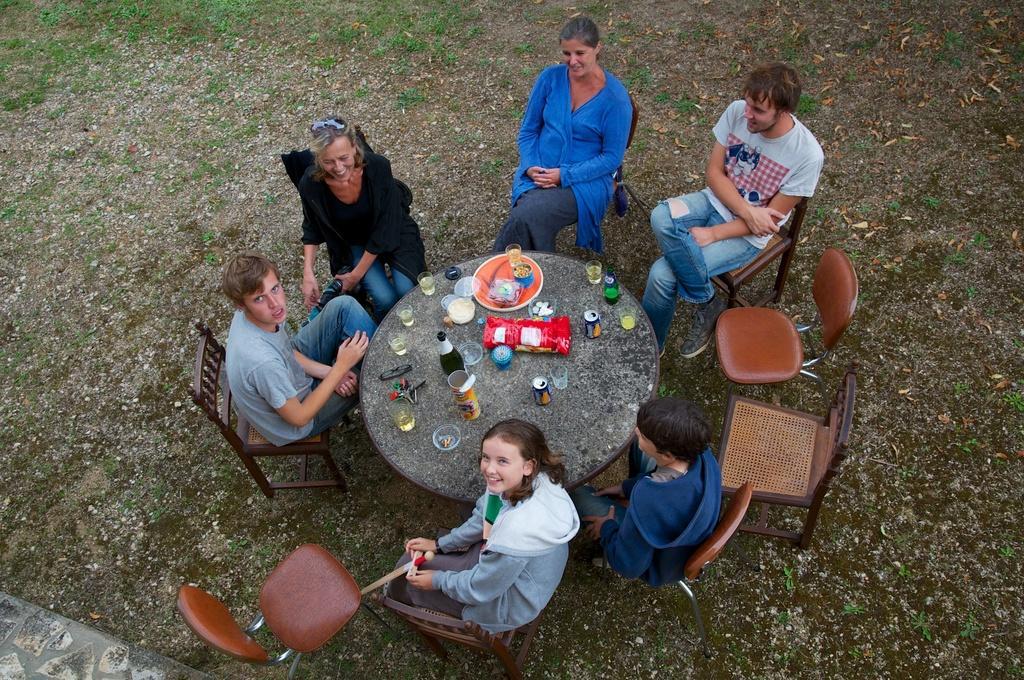Could you give a brief overview of what you see in this image? In this image we can see a group of people sitting on chairs placed on the ground. One girl is holding a sword in her hands. In the center of the image we can see the group of bottles, glasses, plate, cans, spectacles placed on the table. In the background, we can see the grass. 